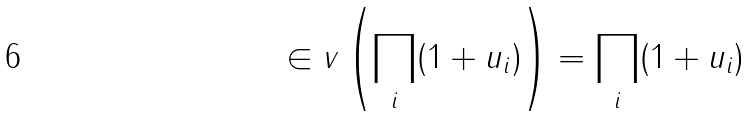<formula> <loc_0><loc_0><loc_500><loc_500>\in v \left ( \prod _ { i } ( 1 + u _ { i } ) \right ) = \prod _ { i } ( 1 + u _ { i } )</formula> 